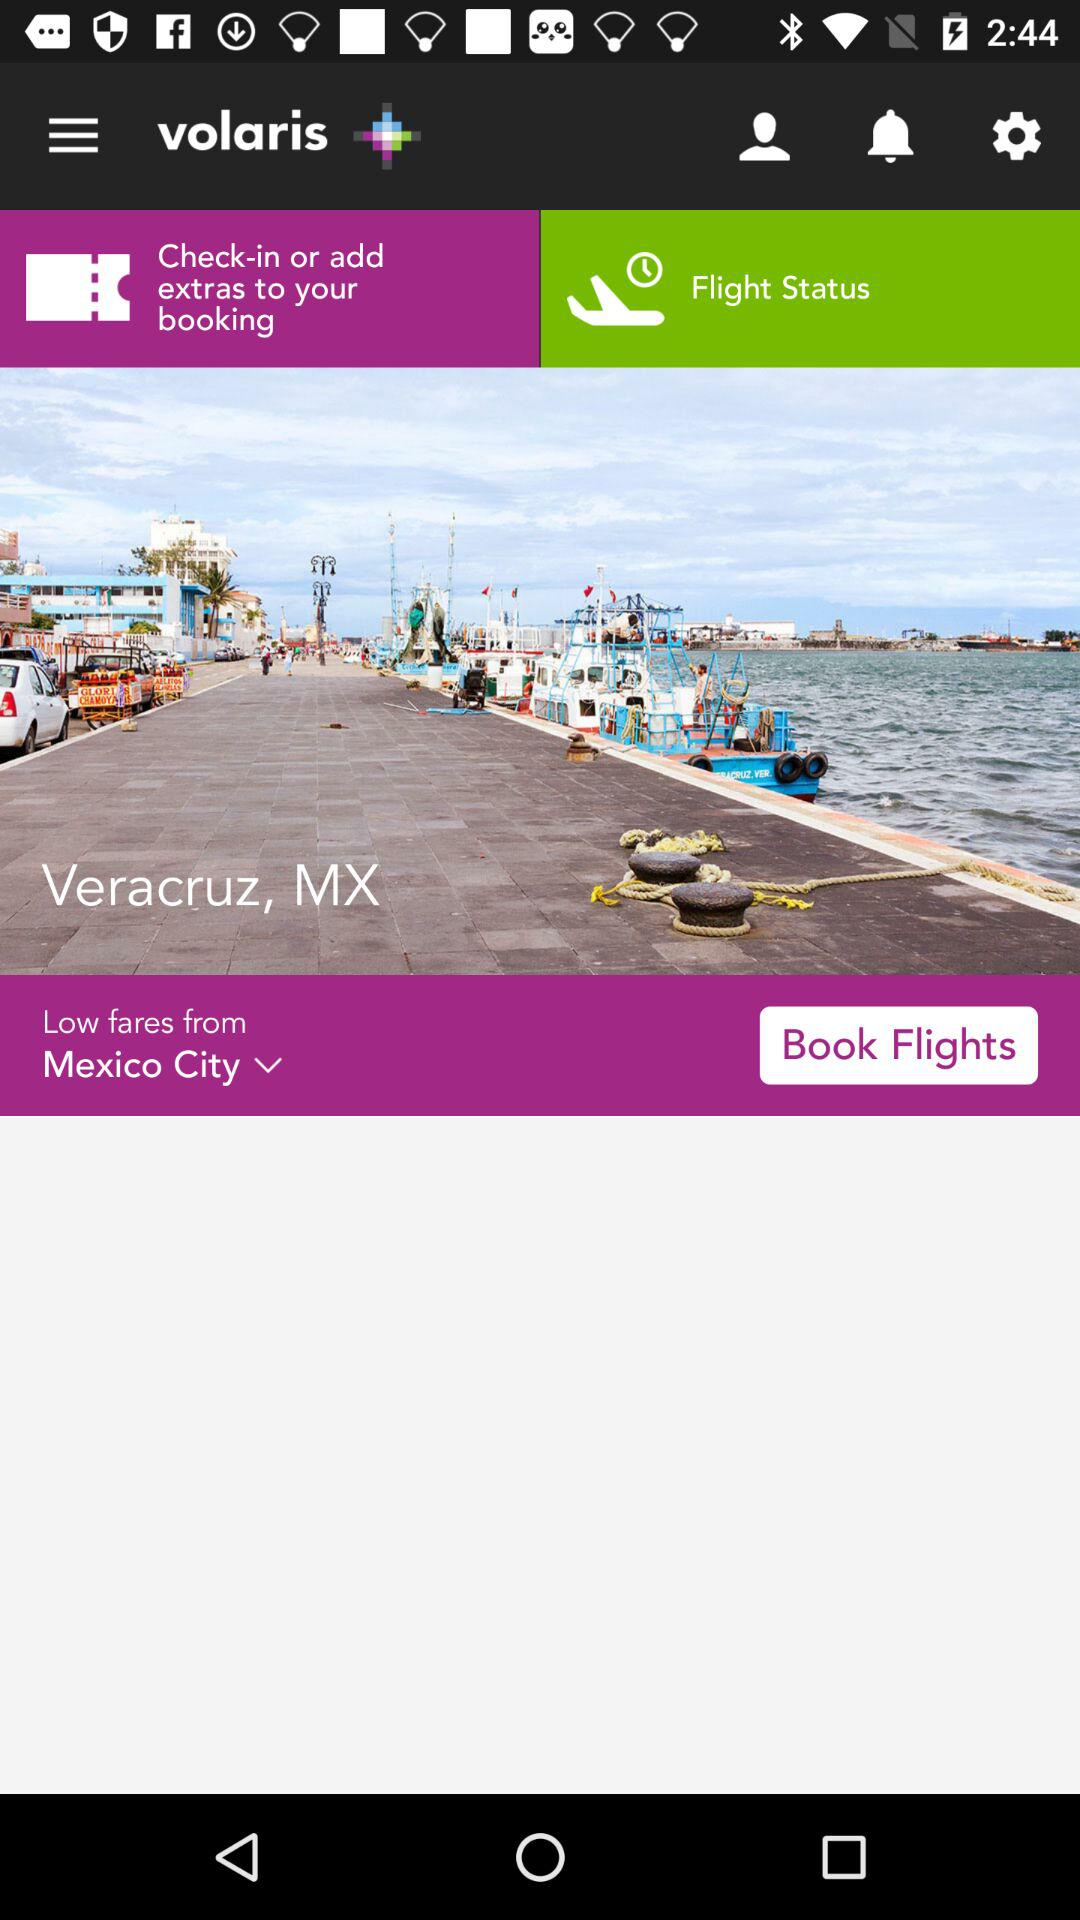What is the status of the flight?
When the provided information is insufficient, respond with <no answer>. <no answer> 